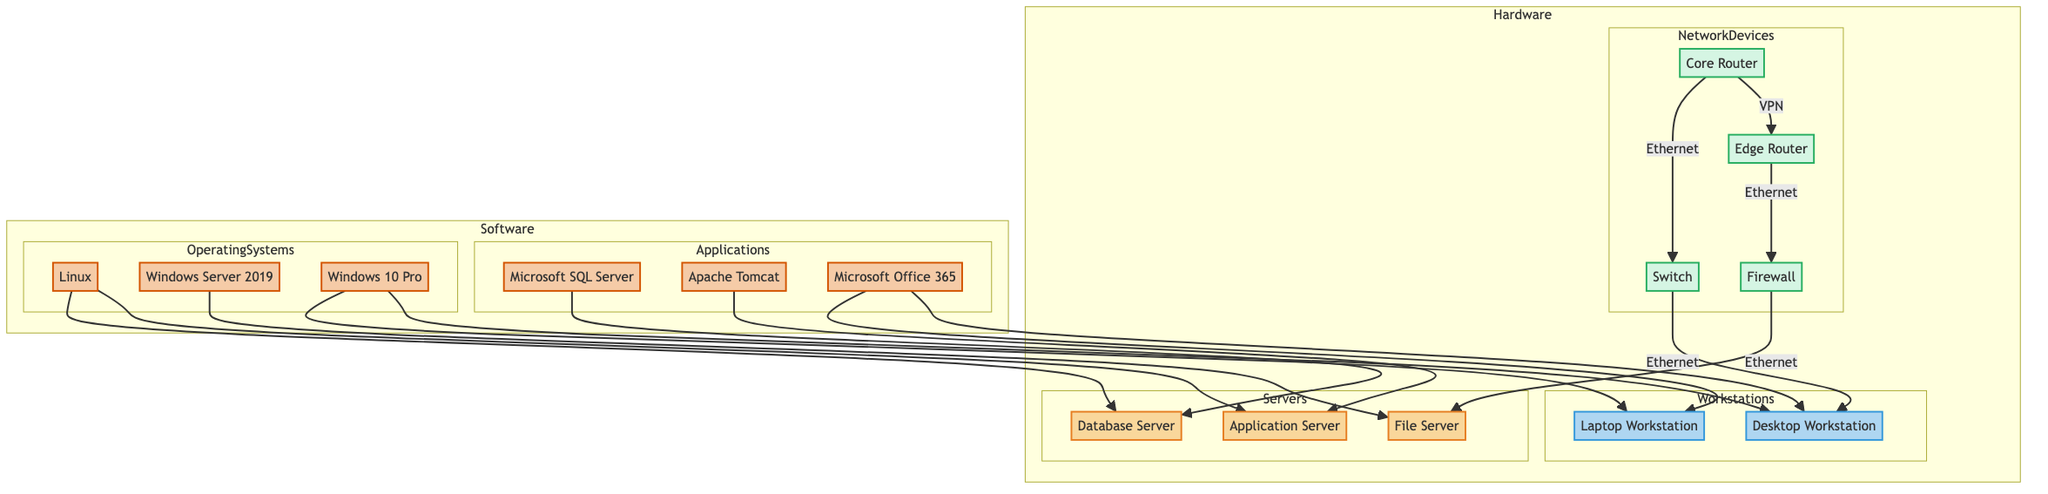What hardware is located in Data Center 1? The diagram indicates two servers are located in Data Center 1: the Application Server and the Database Server.
Answer: Application Server, Database Server What type of router is the Core Router? According to the diagram, the Core Router is represented as a Cisco ASR 9001.
Answer: Cisco ASR 9001 How many workstations are present in the diagram? There are two workstations mentioned: the Desktop Workstation and the Laptop Workstation.
Answer: 2 What type of connection is used between the Core Router and the Switch? The diagram specifies that the connection between the Core Router and the Switch is an Ethernet connection.
Answer: Ethernet Which software is installed on the Application Server? The diagram shows that Apache Tomcat and Linux (Ubuntu 20.04 LTS) are installed on the Application Server.
Answer: Apache Tomcat, Linux What is the relationship between the Firewall and the File Server? The diagram establishes that the Firewall is connected to the File Server via an Ethernet connection.
Answer: Ethernet Which application is linked to the Database Server? Microsoft SQL Server is shown to be installed on the Database Server in the diagram.
Answer: Microsoft SQL Server Where are the devices managed that includes the Edge Router? The Edge Router is located in Branch Office 1 as per the information given in the diagram.
Answer: Branch Office 1 What is the total number of network connections depicted in the diagram? There are five distinct network connections shown in the diagram, connecting hardware components.
Answer: 5 Which operating system is installed on the File Server? According to the diagram, the operating system on the File Server is Windows Server 2019.
Answer: Windows Server 2019 